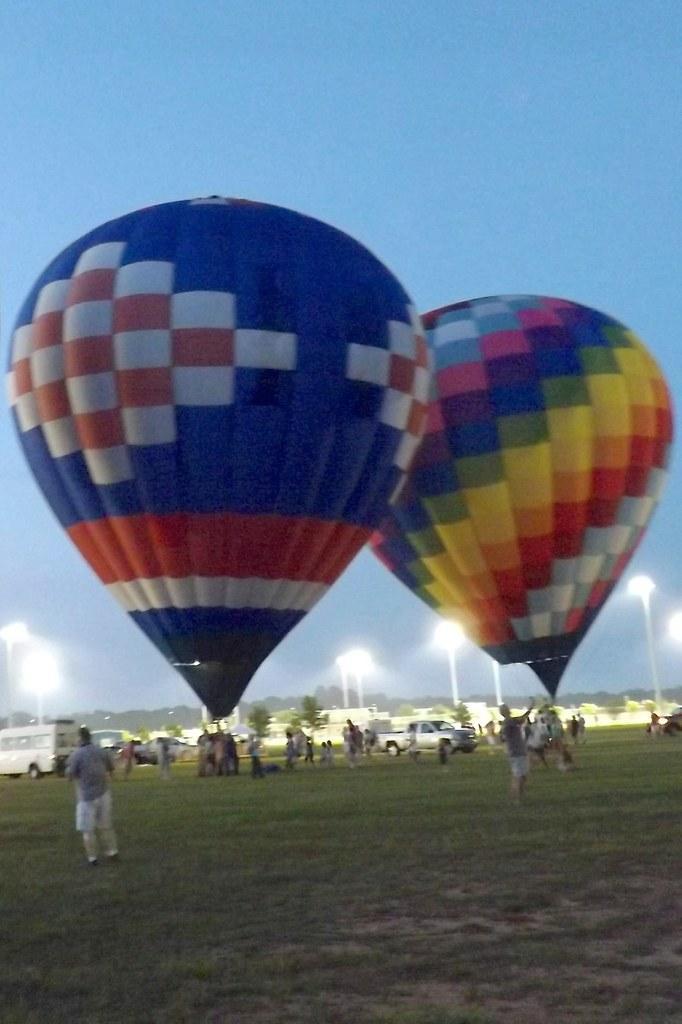Could you give a brief overview of what you see in this image? In this picture there are hot air balloons in the center of the image and there are people and cars at the bottom side of the image, on the grassland. 